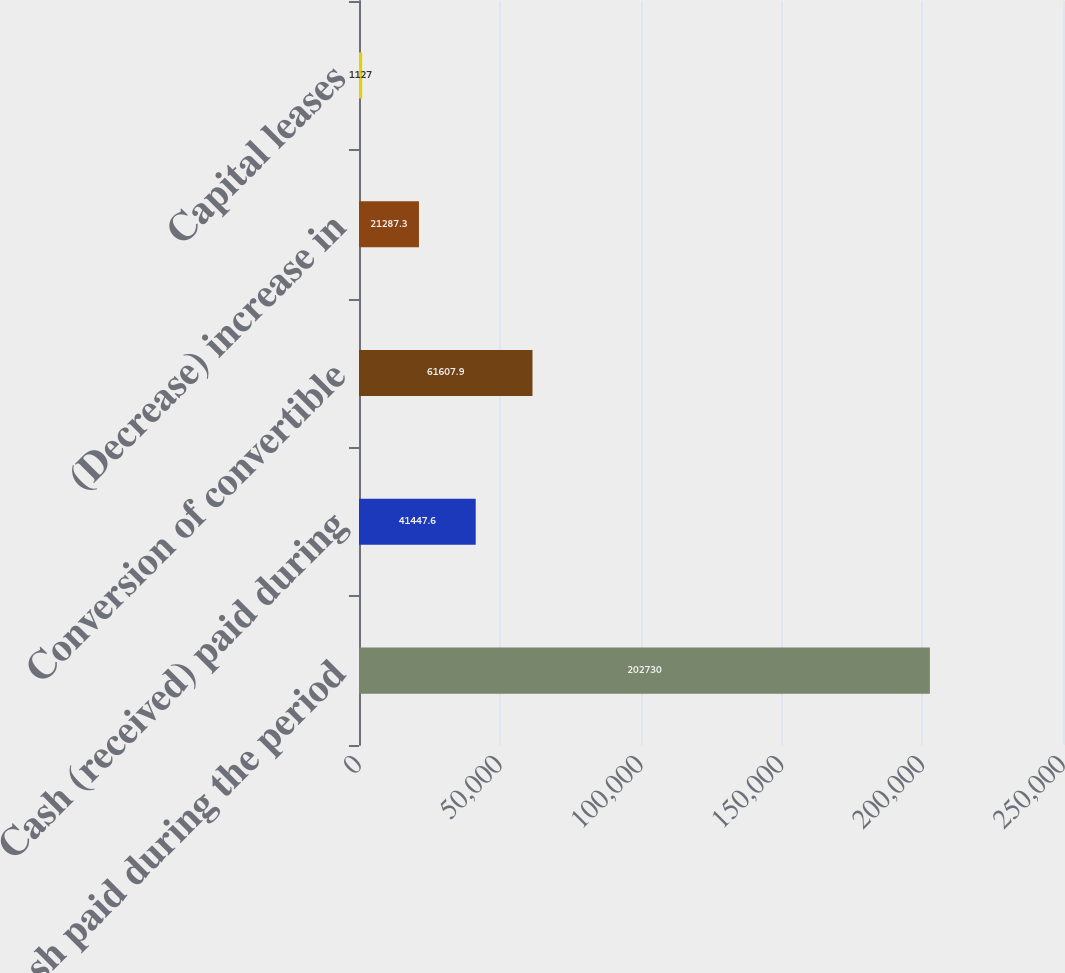Convert chart. <chart><loc_0><loc_0><loc_500><loc_500><bar_chart><fcel>Cash paid during the period<fcel>Cash (received) paid during<fcel>Conversion of convertible<fcel>(Decrease) increase in<fcel>Capital leases<nl><fcel>202730<fcel>41447.6<fcel>61607.9<fcel>21287.3<fcel>1127<nl></chart> 